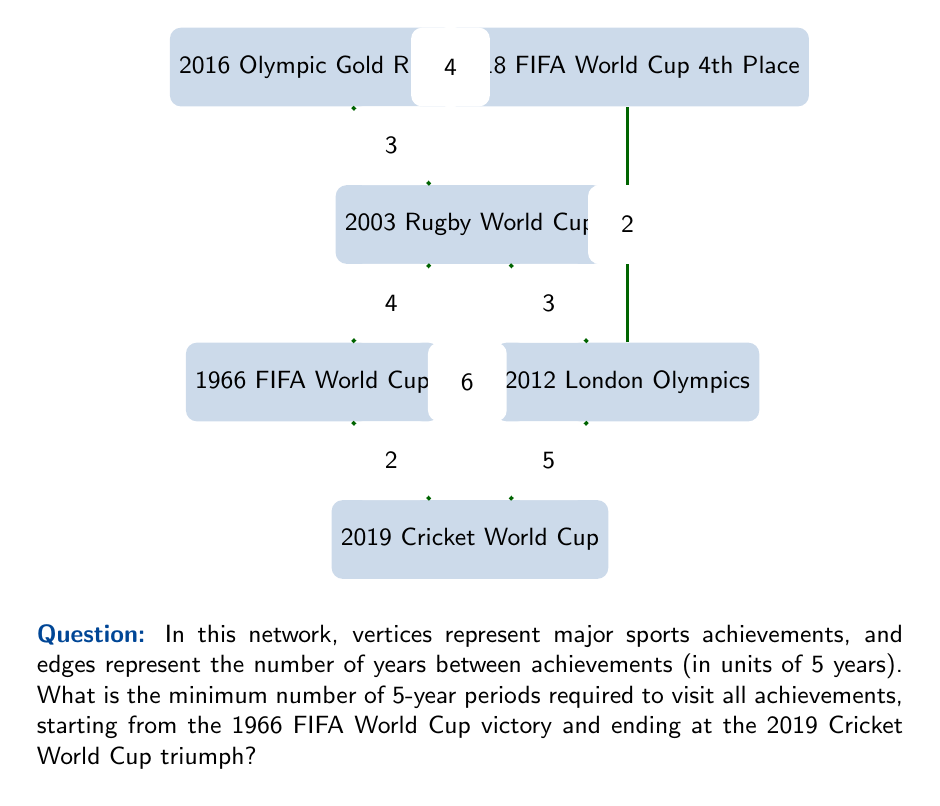Solve this math problem. To solve this problem, we need to find the shortest path that visits all vertices, starting at the 1966 FIFA World Cup (vertex A) and ending at the 2019 Cricket World Cup (vertex D). This is known as the Traveling Salesman Problem (TSP) with a fixed start and end point.

Given the small size of the graph, we can solve this by considering all possible paths:

1. A → B → E → F → C → D: $4 + 3 + 4 + 3 + 5 = 19$
2. A → B → C → F → E → D: $4 + 3 + 2 + 4 + 5 = 18$
3. A → C → B → E → F → D: $6 + 3 + 3 + 4 + 5 = 21$
4. A → C → F → E → B → D: $6 + 2 + 4 + 3 + 5 = 20$

The shortest path is option 2: A → B → C → F → E → D, with a total weight of 18.

Since each unit represents 5 years, we multiply the result by 5:

$$18 \times 5 = 90\text{ years}$$

Therefore, the minimum number of 5-year periods required is 18, which corresponds to 90 years.
Answer: 18 